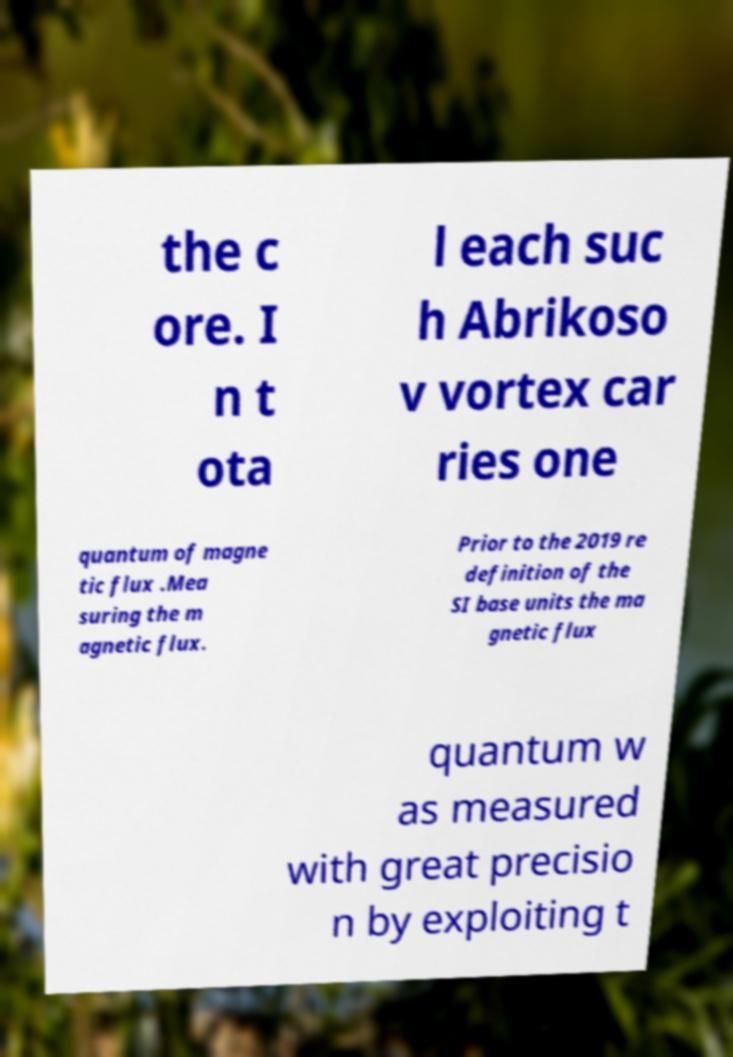Can you accurately transcribe the text from the provided image for me? the c ore. I n t ota l each suc h Abrikoso v vortex car ries one quantum of magne tic flux .Mea suring the m agnetic flux. Prior to the 2019 re definition of the SI base units the ma gnetic flux quantum w as measured with great precisio n by exploiting t 